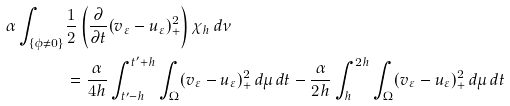Convert formula to latex. <formula><loc_0><loc_0><loc_500><loc_500>\alpha \int _ { \{ \phi \neq 0 \} } & \frac { 1 } { 2 } \left ( \frac { \partial } { \partial t } ( v _ { \varepsilon } - u _ { \varepsilon } ) _ { + } ^ { 2 } \right ) \chi _ { h } \, d \nu \\ & = \frac { \alpha } { 4 h } \int _ { t ^ { \prime } - h } ^ { t ^ { \prime } + h } \int _ { \Omega } ( v _ { \varepsilon } - u _ { \varepsilon } ) _ { + } ^ { 2 } \, d \mu \, d t - \frac { \alpha } { 2 h } \int _ { h } ^ { 2 h } \int _ { \Omega } ( v _ { \varepsilon } - u _ { \varepsilon } ) _ { + } ^ { 2 } \, d \mu \, d t</formula> 